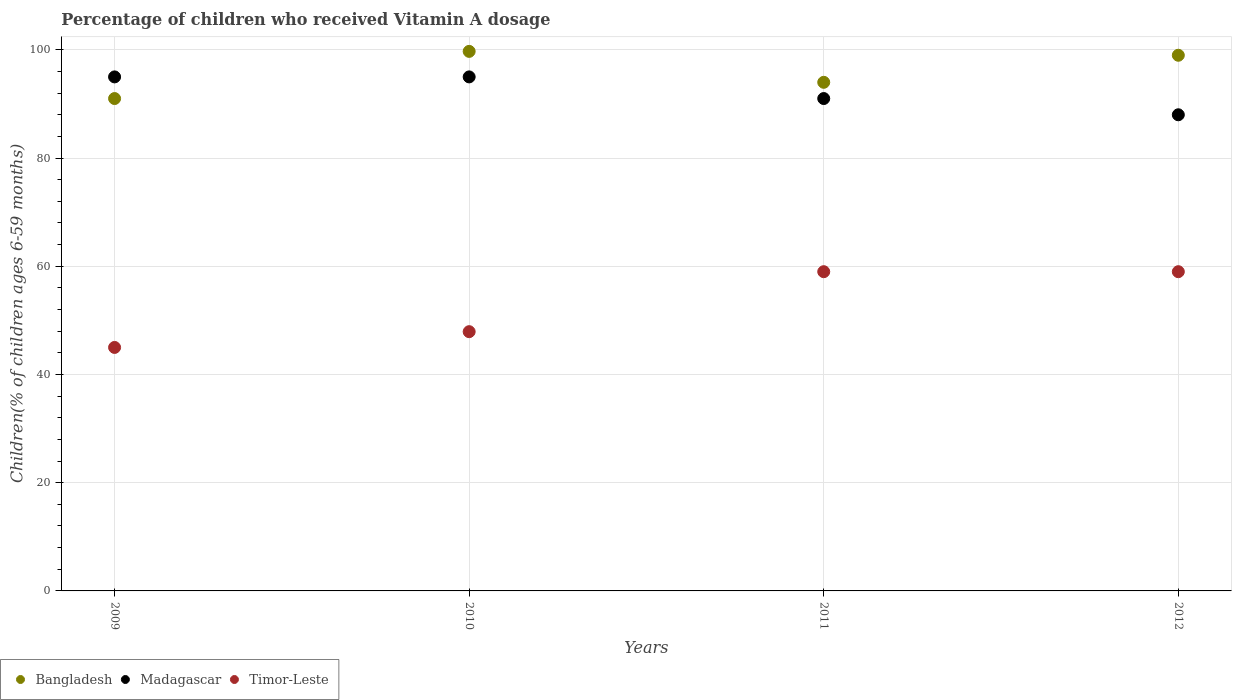How many different coloured dotlines are there?
Your response must be concise. 3. Is the number of dotlines equal to the number of legend labels?
Provide a succinct answer. Yes. Across all years, what is the maximum percentage of children who received Vitamin A dosage in Bangladesh?
Make the answer very short. 99.72. Across all years, what is the minimum percentage of children who received Vitamin A dosage in Madagascar?
Your response must be concise. 88. In which year was the percentage of children who received Vitamin A dosage in Bangladesh maximum?
Give a very brief answer. 2010. What is the total percentage of children who received Vitamin A dosage in Bangladesh in the graph?
Your answer should be compact. 383.72. What is the difference between the percentage of children who received Vitamin A dosage in Madagascar in 2009 and that in 2012?
Give a very brief answer. 7. What is the difference between the percentage of children who received Vitamin A dosage in Madagascar in 2011 and the percentage of children who received Vitamin A dosage in Bangladesh in 2010?
Ensure brevity in your answer.  -8.72. What is the average percentage of children who received Vitamin A dosage in Bangladesh per year?
Your response must be concise. 95.93. In the year 2009, what is the difference between the percentage of children who received Vitamin A dosage in Madagascar and percentage of children who received Vitamin A dosage in Bangladesh?
Your answer should be very brief. 4. In how many years, is the percentage of children who received Vitamin A dosage in Bangladesh greater than 76 %?
Ensure brevity in your answer.  4. What is the ratio of the percentage of children who received Vitamin A dosage in Timor-Leste in 2009 to that in 2010?
Give a very brief answer. 0.94. Is the percentage of children who received Vitamin A dosage in Timor-Leste in 2009 less than that in 2012?
Offer a terse response. Yes. What is the difference between the highest and the second highest percentage of children who received Vitamin A dosage in Bangladesh?
Provide a short and direct response. 0.72. Is it the case that in every year, the sum of the percentage of children who received Vitamin A dosage in Madagascar and percentage of children who received Vitamin A dosage in Bangladesh  is greater than the percentage of children who received Vitamin A dosage in Timor-Leste?
Provide a succinct answer. Yes. Is the percentage of children who received Vitamin A dosage in Madagascar strictly greater than the percentage of children who received Vitamin A dosage in Bangladesh over the years?
Your answer should be very brief. No. What is the difference between two consecutive major ticks on the Y-axis?
Offer a terse response. 20. Does the graph contain any zero values?
Your answer should be very brief. No. Does the graph contain grids?
Keep it short and to the point. Yes. How many legend labels are there?
Provide a succinct answer. 3. What is the title of the graph?
Provide a succinct answer. Percentage of children who received Vitamin A dosage. What is the label or title of the Y-axis?
Offer a terse response. Children(% of children ages 6-59 months). What is the Children(% of children ages 6-59 months) in Bangladesh in 2009?
Your response must be concise. 91. What is the Children(% of children ages 6-59 months) of Madagascar in 2009?
Provide a short and direct response. 95. What is the Children(% of children ages 6-59 months) in Timor-Leste in 2009?
Give a very brief answer. 45. What is the Children(% of children ages 6-59 months) of Bangladesh in 2010?
Make the answer very short. 99.72. What is the Children(% of children ages 6-59 months) in Timor-Leste in 2010?
Your answer should be very brief. 47.91. What is the Children(% of children ages 6-59 months) in Bangladesh in 2011?
Keep it short and to the point. 94. What is the Children(% of children ages 6-59 months) in Madagascar in 2011?
Offer a very short reply. 91. What is the Children(% of children ages 6-59 months) of Timor-Leste in 2011?
Offer a terse response. 59. What is the Children(% of children ages 6-59 months) in Bangladesh in 2012?
Your response must be concise. 99. Across all years, what is the maximum Children(% of children ages 6-59 months) of Bangladesh?
Provide a succinct answer. 99.72. Across all years, what is the maximum Children(% of children ages 6-59 months) of Madagascar?
Offer a terse response. 95. Across all years, what is the minimum Children(% of children ages 6-59 months) in Bangladesh?
Your answer should be very brief. 91. Across all years, what is the minimum Children(% of children ages 6-59 months) of Timor-Leste?
Make the answer very short. 45. What is the total Children(% of children ages 6-59 months) of Bangladesh in the graph?
Keep it short and to the point. 383.72. What is the total Children(% of children ages 6-59 months) of Madagascar in the graph?
Make the answer very short. 369. What is the total Children(% of children ages 6-59 months) in Timor-Leste in the graph?
Your response must be concise. 210.91. What is the difference between the Children(% of children ages 6-59 months) in Bangladesh in 2009 and that in 2010?
Give a very brief answer. -8.72. What is the difference between the Children(% of children ages 6-59 months) of Madagascar in 2009 and that in 2010?
Make the answer very short. 0. What is the difference between the Children(% of children ages 6-59 months) of Timor-Leste in 2009 and that in 2010?
Provide a succinct answer. -2.91. What is the difference between the Children(% of children ages 6-59 months) of Bangladesh in 2009 and that in 2011?
Provide a succinct answer. -3. What is the difference between the Children(% of children ages 6-59 months) in Madagascar in 2009 and that in 2011?
Offer a very short reply. 4. What is the difference between the Children(% of children ages 6-59 months) in Bangladesh in 2009 and that in 2012?
Offer a terse response. -8. What is the difference between the Children(% of children ages 6-59 months) of Timor-Leste in 2009 and that in 2012?
Give a very brief answer. -14. What is the difference between the Children(% of children ages 6-59 months) of Bangladesh in 2010 and that in 2011?
Give a very brief answer. 5.72. What is the difference between the Children(% of children ages 6-59 months) in Timor-Leste in 2010 and that in 2011?
Ensure brevity in your answer.  -11.09. What is the difference between the Children(% of children ages 6-59 months) in Bangladesh in 2010 and that in 2012?
Ensure brevity in your answer.  0.72. What is the difference between the Children(% of children ages 6-59 months) in Timor-Leste in 2010 and that in 2012?
Ensure brevity in your answer.  -11.09. What is the difference between the Children(% of children ages 6-59 months) in Madagascar in 2011 and that in 2012?
Your answer should be compact. 3. What is the difference between the Children(% of children ages 6-59 months) of Timor-Leste in 2011 and that in 2012?
Keep it short and to the point. 0. What is the difference between the Children(% of children ages 6-59 months) of Bangladesh in 2009 and the Children(% of children ages 6-59 months) of Madagascar in 2010?
Your answer should be compact. -4. What is the difference between the Children(% of children ages 6-59 months) in Bangladesh in 2009 and the Children(% of children ages 6-59 months) in Timor-Leste in 2010?
Make the answer very short. 43.09. What is the difference between the Children(% of children ages 6-59 months) in Madagascar in 2009 and the Children(% of children ages 6-59 months) in Timor-Leste in 2010?
Provide a short and direct response. 47.09. What is the difference between the Children(% of children ages 6-59 months) in Bangladesh in 2009 and the Children(% of children ages 6-59 months) in Madagascar in 2011?
Offer a very short reply. 0. What is the difference between the Children(% of children ages 6-59 months) in Madagascar in 2009 and the Children(% of children ages 6-59 months) in Timor-Leste in 2011?
Your response must be concise. 36. What is the difference between the Children(% of children ages 6-59 months) in Bangladesh in 2009 and the Children(% of children ages 6-59 months) in Madagascar in 2012?
Keep it short and to the point. 3. What is the difference between the Children(% of children ages 6-59 months) of Madagascar in 2009 and the Children(% of children ages 6-59 months) of Timor-Leste in 2012?
Give a very brief answer. 36. What is the difference between the Children(% of children ages 6-59 months) of Bangladesh in 2010 and the Children(% of children ages 6-59 months) of Madagascar in 2011?
Give a very brief answer. 8.72. What is the difference between the Children(% of children ages 6-59 months) in Bangladesh in 2010 and the Children(% of children ages 6-59 months) in Timor-Leste in 2011?
Give a very brief answer. 40.72. What is the difference between the Children(% of children ages 6-59 months) in Bangladesh in 2010 and the Children(% of children ages 6-59 months) in Madagascar in 2012?
Offer a terse response. 11.72. What is the difference between the Children(% of children ages 6-59 months) of Bangladesh in 2010 and the Children(% of children ages 6-59 months) of Timor-Leste in 2012?
Provide a short and direct response. 40.72. What is the difference between the Children(% of children ages 6-59 months) of Madagascar in 2011 and the Children(% of children ages 6-59 months) of Timor-Leste in 2012?
Keep it short and to the point. 32. What is the average Children(% of children ages 6-59 months) in Bangladesh per year?
Offer a very short reply. 95.93. What is the average Children(% of children ages 6-59 months) in Madagascar per year?
Your answer should be very brief. 92.25. What is the average Children(% of children ages 6-59 months) in Timor-Leste per year?
Your answer should be very brief. 52.73. In the year 2009, what is the difference between the Children(% of children ages 6-59 months) of Bangladesh and Children(% of children ages 6-59 months) of Madagascar?
Offer a terse response. -4. In the year 2009, what is the difference between the Children(% of children ages 6-59 months) of Madagascar and Children(% of children ages 6-59 months) of Timor-Leste?
Give a very brief answer. 50. In the year 2010, what is the difference between the Children(% of children ages 6-59 months) in Bangladesh and Children(% of children ages 6-59 months) in Madagascar?
Provide a short and direct response. 4.72. In the year 2010, what is the difference between the Children(% of children ages 6-59 months) of Bangladesh and Children(% of children ages 6-59 months) of Timor-Leste?
Make the answer very short. 51.8. In the year 2010, what is the difference between the Children(% of children ages 6-59 months) of Madagascar and Children(% of children ages 6-59 months) of Timor-Leste?
Make the answer very short. 47.09. In the year 2012, what is the difference between the Children(% of children ages 6-59 months) in Bangladesh and Children(% of children ages 6-59 months) in Madagascar?
Give a very brief answer. 11. In the year 2012, what is the difference between the Children(% of children ages 6-59 months) in Bangladesh and Children(% of children ages 6-59 months) in Timor-Leste?
Your answer should be very brief. 40. What is the ratio of the Children(% of children ages 6-59 months) in Bangladesh in 2009 to that in 2010?
Give a very brief answer. 0.91. What is the ratio of the Children(% of children ages 6-59 months) in Timor-Leste in 2009 to that in 2010?
Offer a very short reply. 0.94. What is the ratio of the Children(% of children ages 6-59 months) in Bangladesh in 2009 to that in 2011?
Provide a short and direct response. 0.97. What is the ratio of the Children(% of children ages 6-59 months) of Madagascar in 2009 to that in 2011?
Make the answer very short. 1.04. What is the ratio of the Children(% of children ages 6-59 months) of Timor-Leste in 2009 to that in 2011?
Ensure brevity in your answer.  0.76. What is the ratio of the Children(% of children ages 6-59 months) of Bangladesh in 2009 to that in 2012?
Your answer should be very brief. 0.92. What is the ratio of the Children(% of children ages 6-59 months) in Madagascar in 2009 to that in 2012?
Offer a terse response. 1.08. What is the ratio of the Children(% of children ages 6-59 months) in Timor-Leste in 2009 to that in 2012?
Offer a very short reply. 0.76. What is the ratio of the Children(% of children ages 6-59 months) of Bangladesh in 2010 to that in 2011?
Offer a very short reply. 1.06. What is the ratio of the Children(% of children ages 6-59 months) of Madagascar in 2010 to that in 2011?
Ensure brevity in your answer.  1.04. What is the ratio of the Children(% of children ages 6-59 months) in Timor-Leste in 2010 to that in 2011?
Ensure brevity in your answer.  0.81. What is the ratio of the Children(% of children ages 6-59 months) of Madagascar in 2010 to that in 2012?
Offer a very short reply. 1.08. What is the ratio of the Children(% of children ages 6-59 months) of Timor-Leste in 2010 to that in 2012?
Your answer should be very brief. 0.81. What is the ratio of the Children(% of children ages 6-59 months) of Bangladesh in 2011 to that in 2012?
Ensure brevity in your answer.  0.95. What is the ratio of the Children(% of children ages 6-59 months) of Madagascar in 2011 to that in 2012?
Offer a terse response. 1.03. What is the difference between the highest and the second highest Children(% of children ages 6-59 months) in Bangladesh?
Offer a very short reply. 0.72. What is the difference between the highest and the second highest Children(% of children ages 6-59 months) in Madagascar?
Offer a very short reply. 0. What is the difference between the highest and the second highest Children(% of children ages 6-59 months) of Timor-Leste?
Provide a succinct answer. 0. What is the difference between the highest and the lowest Children(% of children ages 6-59 months) of Bangladesh?
Ensure brevity in your answer.  8.72. 